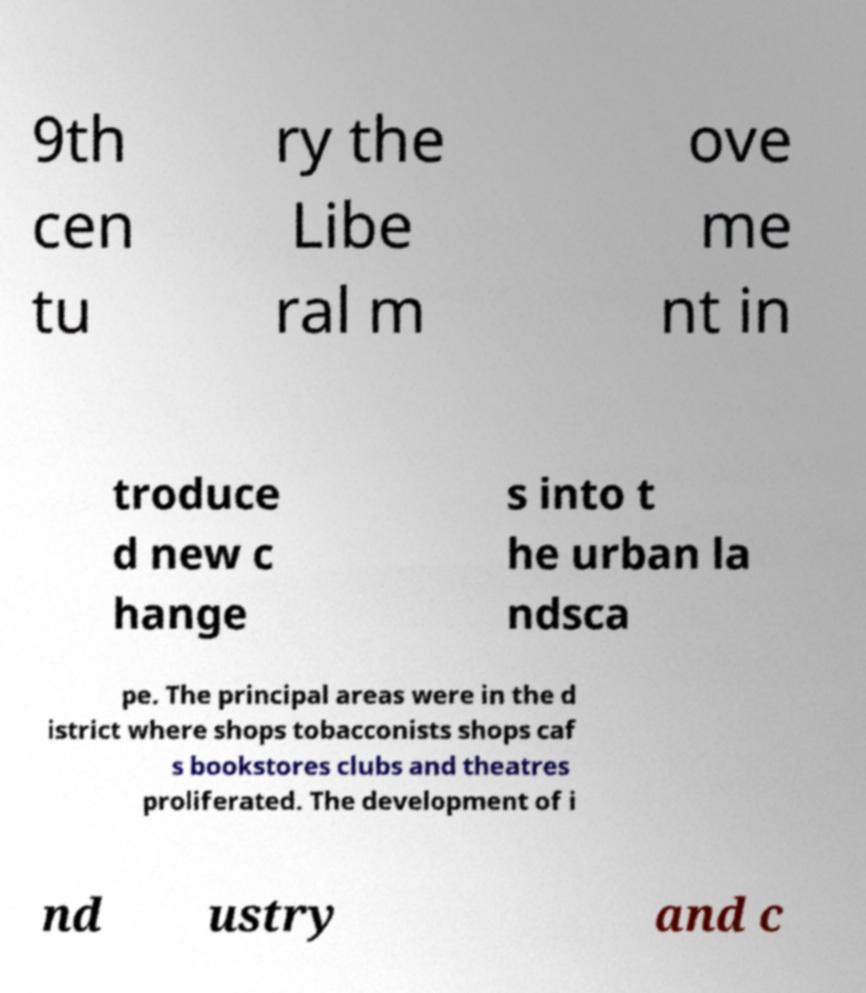I need the written content from this picture converted into text. Can you do that? 9th cen tu ry the Libe ral m ove me nt in troduce d new c hange s into t he urban la ndsca pe. The principal areas were in the d istrict where shops tobacconists shops caf s bookstores clubs and theatres proliferated. The development of i nd ustry and c 